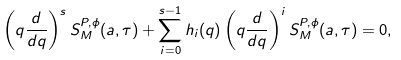<formula> <loc_0><loc_0><loc_500><loc_500>\left ( q \frac { d } { d q } \right ) ^ { s } S _ { M } ^ { P , \phi } ( a , \tau ) + \sum _ { i = 0 } ^ { s - 1 } h _ { i } ( q ) \left ( q \frac { d } { d q } \right ) ^ { i } S _ { M } ^ { P , \phi } ( a , \tau ) = 0 ,</formula> 